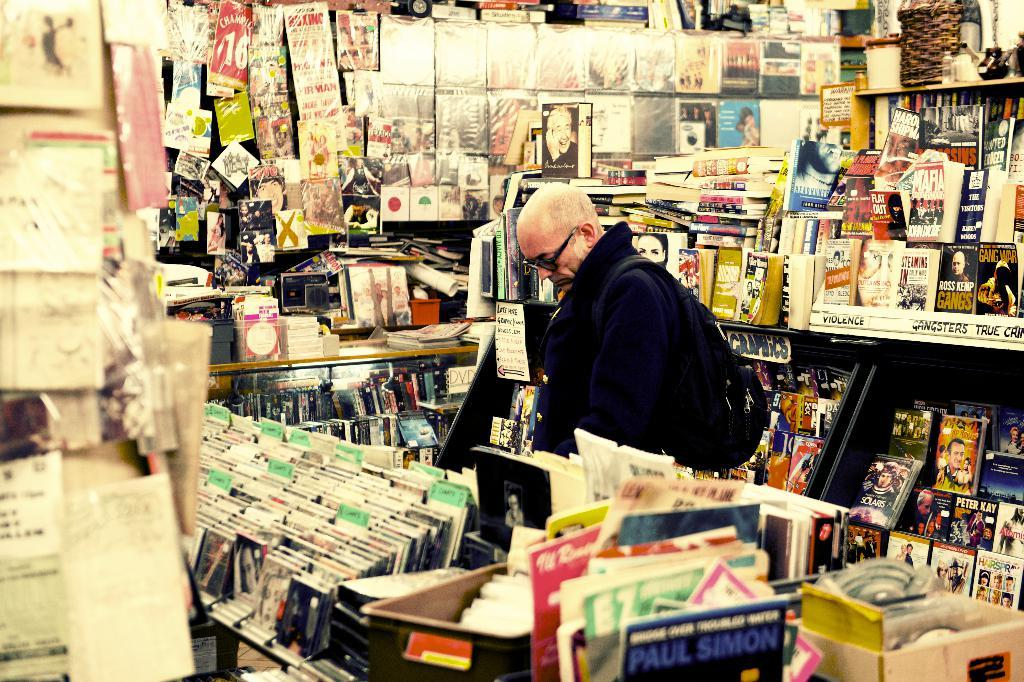<image>
Share a concise interpretation of the image provided. Man in a music store with a Paul Simon album in the front. 